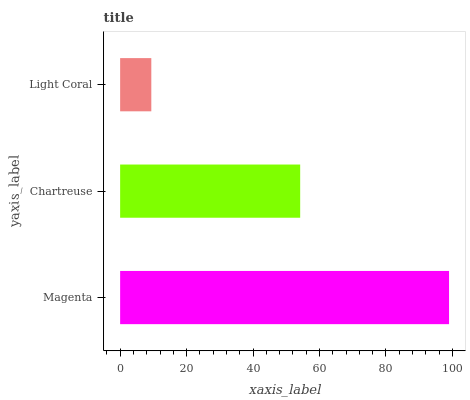Is Light Coral the minimum?
Answer yes or no. Yes. Is Magenta the maximum?
Answer yes or no. Yes. Is Chartreuse the minimum?
Answer yes or no. No. Is Chartreuse the maximum?
Answer yes or no. No. Is Magenta greater than Chartreuse?
Answer yes or no. Yes. Is Chartreuse less than Magenta?
Answer yes or no. Yes. Is Chartreuse greater than Magenta?
Answer yes or no. No. Is Magenta less than Chartreuse?
Answer yes or no. No. Is Chartreuse the high median?
Answer yes or no. Yes. Is Chartreuse the low median?
Answer yes or no. Yes. Is Light Coral the high median?
Answer yes or no. No. Is Magenta the low median?
Answer yes or no. No. 